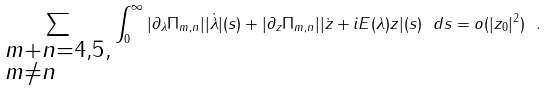Convert formula to latex. <formula><loc_0><loc_0><loc_500><loc_500>\sum _ { \begin{subarray} { l l l } m + n = 4 , 5 , \\ m \not = n \end{subarray} } \int _ { 0 } ^ { \infty } | \partial _ { \lambda } \Pi _ { m , n } | | \dot { \lambda } | ( s ) + | \partial _ { z } \Pi _ { m , n } | | \dot { z } + i E ( \lambda ) z | ( s ) \ d s = o ( | z _ { 0 } | ^ { 2 } ) \ .</formula> 